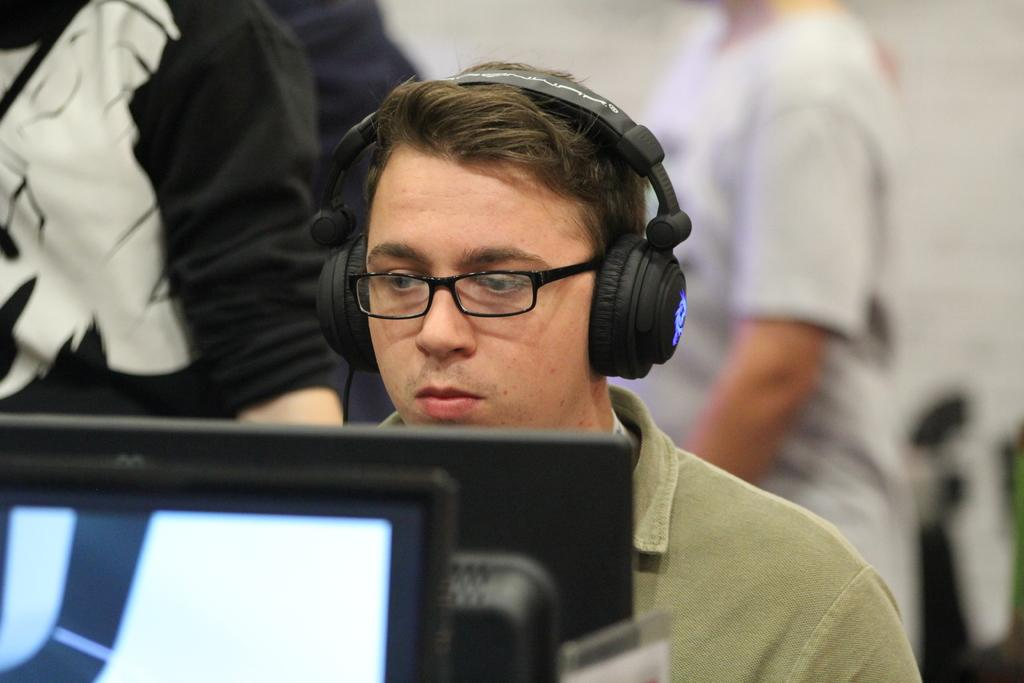What is there is a person in the image, what are they doing? The person in the image is wearing headphones and looking at a monitor. Can you describe the position of the monitor in relation to the person? The monitor is in front of the person. Are there any other people visible in the image? Yes, there are other people walking behind the image. What might the person be listening to while looking at the monitor? It is not possible to determine what the person is listening to from the image alone. What type of pear is being used as a cracker in the image? There is no pear or cracker present in the image. 